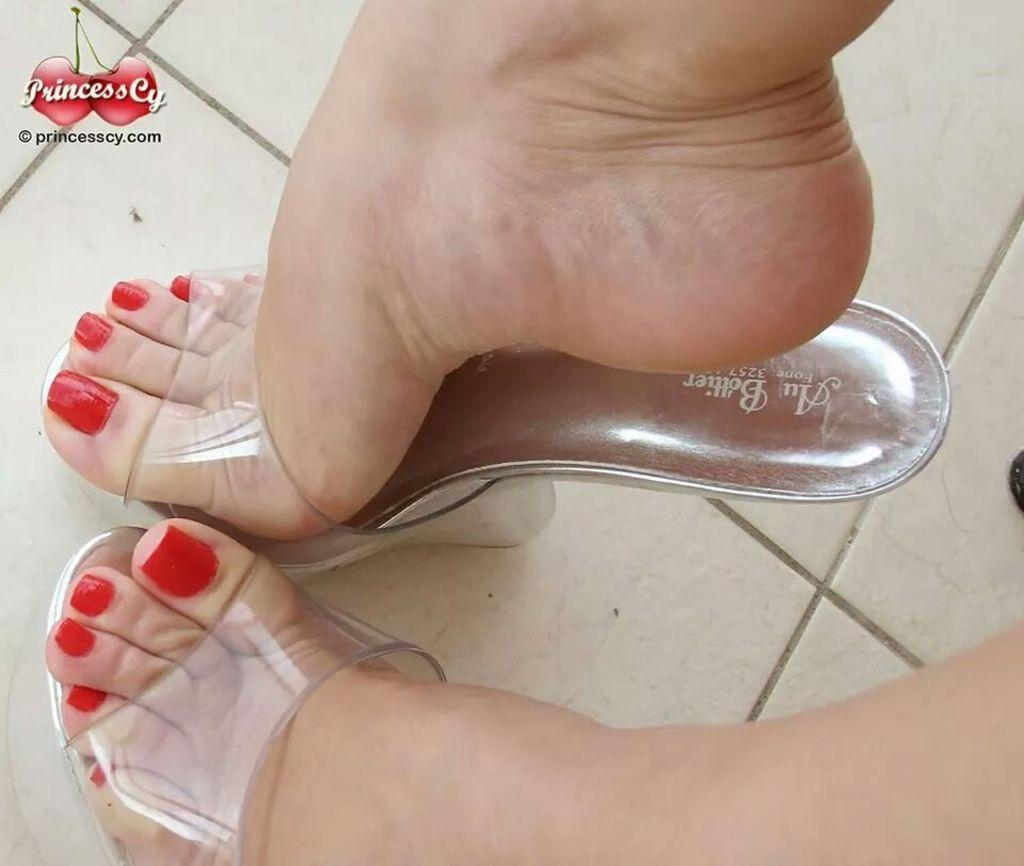What body part is visible in the image? There are a person's legs visible in the image. What is the person wearing on their feet? The person is wearing footwear in the image. What can be seen beneath the person's legs? The surface the person is standing on is visible in the image. What is located in the top left corner of the image? There is a logo in the top left corner of the image. What type of underwear is the person wearing in the image? The image does not show the person's underwear, so it cannot be determined from the image. --- Facts: 1. There is a person holding a book in the image. 2. The book has a blue cover. 3. The person is sitting on a chair. 4. There is a table next to the chair. 5. The table has a lamp on it. Absurd Topics: dance, ocean, parrot Conversation: What is the person holding in the image? The person is holding a book in the image. What color is the book's cover? The book has a blue cover. Where is the person sitting in the image? The person is sitting on a chair in the image. What is located next to the chair? There is a table next to the chair in the image. What object is on the table? The table has a lamp on it in the image. Reasoning: Let's think step by step in order to produce the conversation. We start by identifying the main subject in the image, which is the person holding a book. Then, we expand the conversation to include details about the book's cover, the person's seating arrangement, and the objects on the table. Each question is designed to elicit a specific detail about the image that is known from the provided facts. Absurd Question/Answer: Can you see any parrots flying over the ocean in the image? There is no ocean or parrots present in the image; it features a person holding a book and sitting on a chair with a table and lamp nearby. 